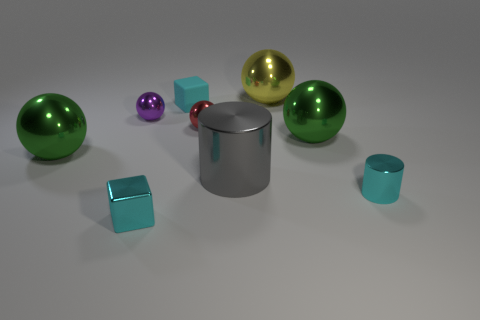What is the shape of the big gray object in front of the cyan matte thing that is on the left side of the large green metal ball on the right side of the small red metal object?
Provide a short and direct response. Cylinder. How many other things are there of the same color as the small metallic cylinder?
Offer a very short reply. 2. The tiny cyan thing that is to the right of the green ball right of the large yellow sphere is what shape?
Your answer should be very brief. Cylinder. What number of big spheres are behind the yellow sphere?
Make the answer very short. 0. Are there any other small purple things made of the same material as the tiny purple object?
Your answer should be very brief. No. What is the material of the gray thing that is the same size as the yellow shiny object?
Offer a terse response. Metal. How big is the cyan thing that is both in front of the tiny rubber block and on the left side of the red shiny object?
Make the answer very short. Small. The tiny thing that is both in front of the tiny red metallic object and on the left side of the small cyan cylinder is what color?
Your answer should be very brief. Cyan. Is the number of cyan metal objects to the right of the tiny metallic cylinder less than the number of cyan rubber things that are in front of the small metal cube?
Provide a short and direct response. No. What number of other big yellow objects are the same shape as the rubber thing?
Give a very brief answer. 0. 